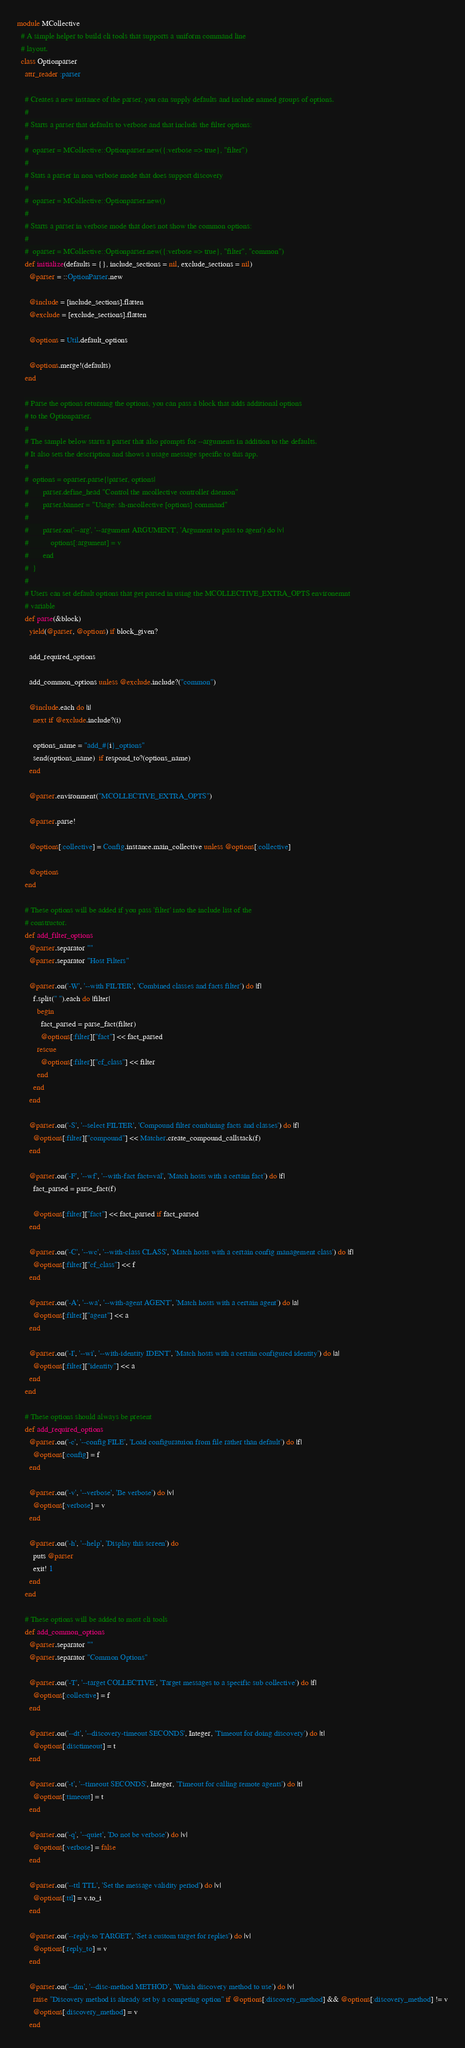Convert code to text. <code><loc_0><loc_0><loc_500><loc_500><_Ruby_>module MCollective
  # A simple helper to build cli tools that supports a uniform command line
  # layout.
  class Optionparser
    attr_reader :parser

    # Creates a new instance of the parser, you can supply defaults and include named groups of options.
    #
    # Starts a parser that defaults to verbose and that includs the filter options:
    #
    #  oparser = MCollective::Optionparser.new({:verbose => true}, "filter")
    #
    # Stats a parser in non verbose mode that does support discovery
    #
    #  oparser = MCollective::Optionparser.new()
    #
    # Starts a parser in verbose mode that does not show the common options:
    #
    #  oparser = MCollective::Optionparser.new({:verbose => true}, "filter", "common")
    def initialize(defaults = {}, include_sections = nil, exclude_sections = nil)
      @parser = ::OptionParser.new

      @include = [include_sections].flatten
      @exclude = [exclude_sections].flatten

      @options = Util.default_options

      @options.merge!(defaults)
    end

    # Parse the options returning the options, you can pass a block that adds additional options
    # to the Optionparser.
    #
    # The sample below starts a parser that also prompts for --arguments in addition to the defaults.
    # It also sets the description and shows a usage message specific to this app.
    #
    #  options = oparser.parse{|parser, options|
    #       parser.define_head "Control the mcollective controller daemon"
    #       parser.banner = "Usage: sh-mcollective [options] command"
    #
    #       parser.on('--arg', '--argument ARGUMENT', 'Argument to pass to agent') do |v|
    #           options[:argument] = v
    #       end
    #  }
    #
    # Users can set default options that get parsed in using the MCOLLECTIVE_EXTRA_OPTS environemnt
    # variable
    def parse(&block)
      yield(@parser, @options) if block_given?

      add_required_options

      add_common_options unless @exclude.include?("common")

      @include.each do |i|
        next if @exclude.include?(i)

        options_name = "add_#{i}_options"
        send(options_name)  if respond_to?(options_name)
      end

      @parser.environment("MCOLLECTIVE_EXTRA_OPTS")

      @parser.parse!

      @options[:collective] = Config.instance.main_collective unless @options[:collective]

      @options
    end

    # These options will be added if you pass 'filter' into the include list of the
    # constructor.
    def add_filter_options
      @parser.separator ""
      @parser.separator "Host Filters"

      @parser.on('-W', '--with FILTER', 'Combined classes and facts filter') do |f|
        f.split(" ").each do |filter|
          begin
            fact_parsed = parse_fact(filter)
            @options[:filter]["fact"] << fact_parsed
          rescue
            @options[:filter]["cf_class"] << filter
          end
        end
      end

      @parser.on('-S', '--select FILTER', 'Compound filter combining facts and classes') do |f|
        @options[:filter]["compound"] << Matcher.create_compound_callstack(f)
      end

      @parser.on('-F', '--wf', '--with-fact fact=val', 'Match hosts with a certain fact') do |f|
        fact_parsed = parse_fact(f)

        @options[:filter]["fact"] << fact_parsed if fact_parsed
      end

      @parser.on('-C', '--wc', '--with-class CLASS', 'Match hosts with a certain config management class') do |f|
        @options[:filter]["cf_class"] << f
      end

      @parser.on('-A', '--wa', '--with-agent AGENT', 'Match hosts with a certain agent') do |a|
        @options[:filter]["agent"] << a
      end

      @parser.on('-I', '--wi', '--with-identity IDENT', 'Match hosts with a certain configured identity') do |a|
        @options[:filter]["identity"] << a
      end
    end

    # These options should always be present
    def add_required_options
      @parser.on('-c', '--config FILE', 'Load configuratuion from file rather than default') do |f|
        @options[:config] = f
      end

      @parser.on('-v', '--verbose', 'Be verbose') do |v|
        @options[:verbose] = v
      end

      @parser.on('-h', '--help', 'Display this screen') do
        puts @parser
        exit! 1
      end
    end

    # These options will be added to most cli tools
    def add_common_options
      @parser.separator ""
      @parser.separator "Common Options"

      @parser.on('-T', '--target COLLECTIVE', 'Target messages to a specific sub collective') do |f|
        @options[:collective] = f
      end

      @parser.on('--dt', '--discovery-timeout SECONDS', Integer, 'Timeout for doing discovery') do |t|
        @options[:disctimeout] = t
      end

      @parser.on('-t', '--timeout SECONDS', Integer, 'Timeout for calling remote agents') do |t|
        @options[:timeout] = t
      end

      @parser.on('-q', '--quiet', 'Do not be verbose') do |v|
        @options[:verbose] = false
      end

      @parser.on('--ttl TTL', 'Set the message validity period') do |v|
        @options[:ttl] = v.to_i
      end

      @parser.on('--reply-to TARGET', 'Set a custom target for replies') do |v|
        @options[:reply_to] = v
      end

      @parser.on('--dm', '--disc-method METHOD', 'Which discovery method to use') do |v|
        raise "Discovery method is already set by a competing option" if @options[:discovery_method] && @options[:discovery_method] != v
        @options[:discovery_method] = v
      end
</code> 